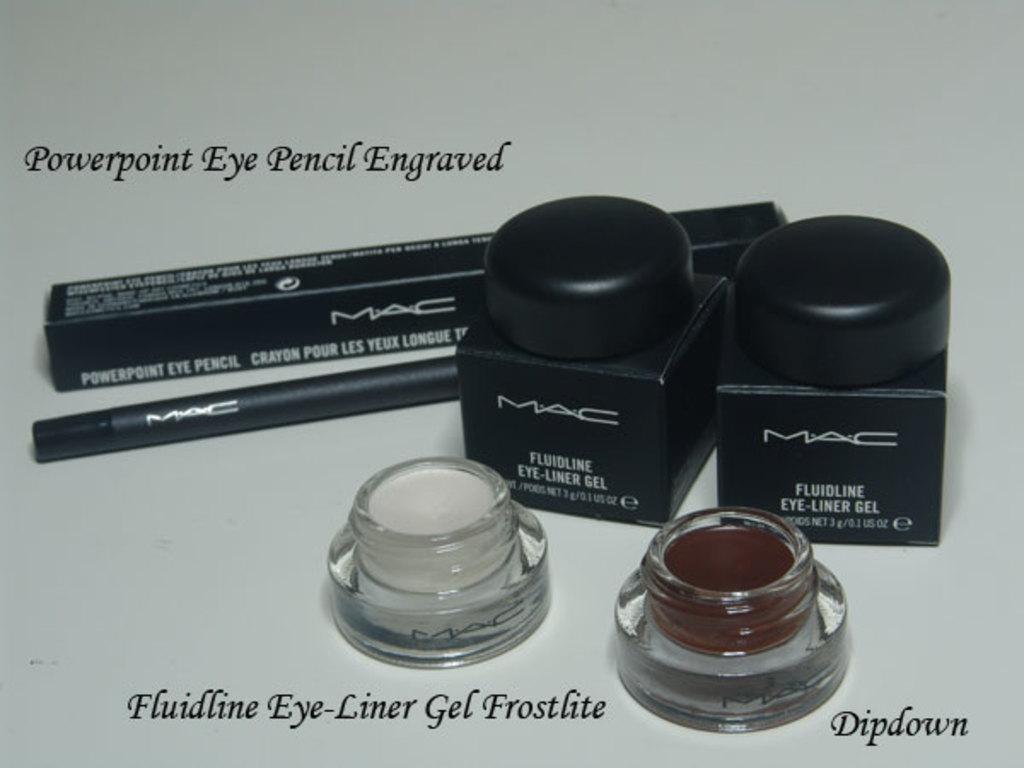<image>
Describe the image concisely. Fluidline Eye-Liner Gel Frostbite is the caption of this makeup advert. 